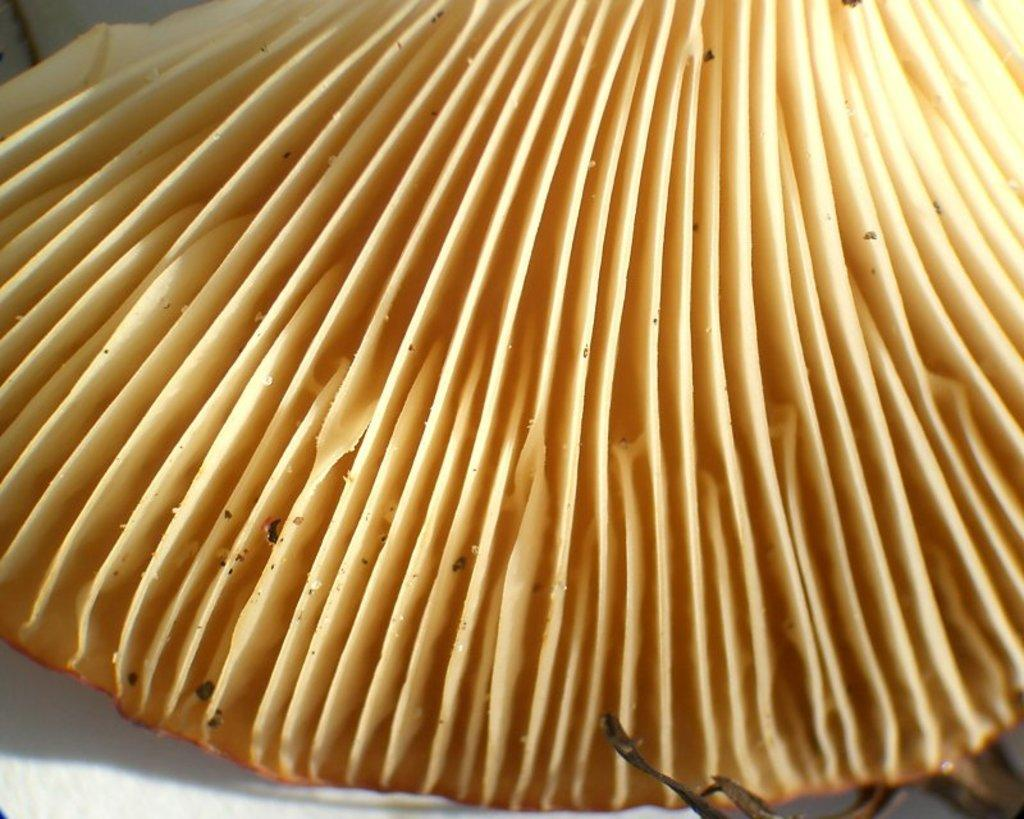What is the main subject of the image? The main subject of the image is a shell-type object. Can you describe the appearance of the shell-type object? The shell-type object is in cream and brown color. Are there any other objects present in the image? Yes, there are a few other objects in the image. How does the wealth of the brothers affect the pump in the image? There is no mention of wealth, brothers, or a pump in the image, so this question cannot be answered. 